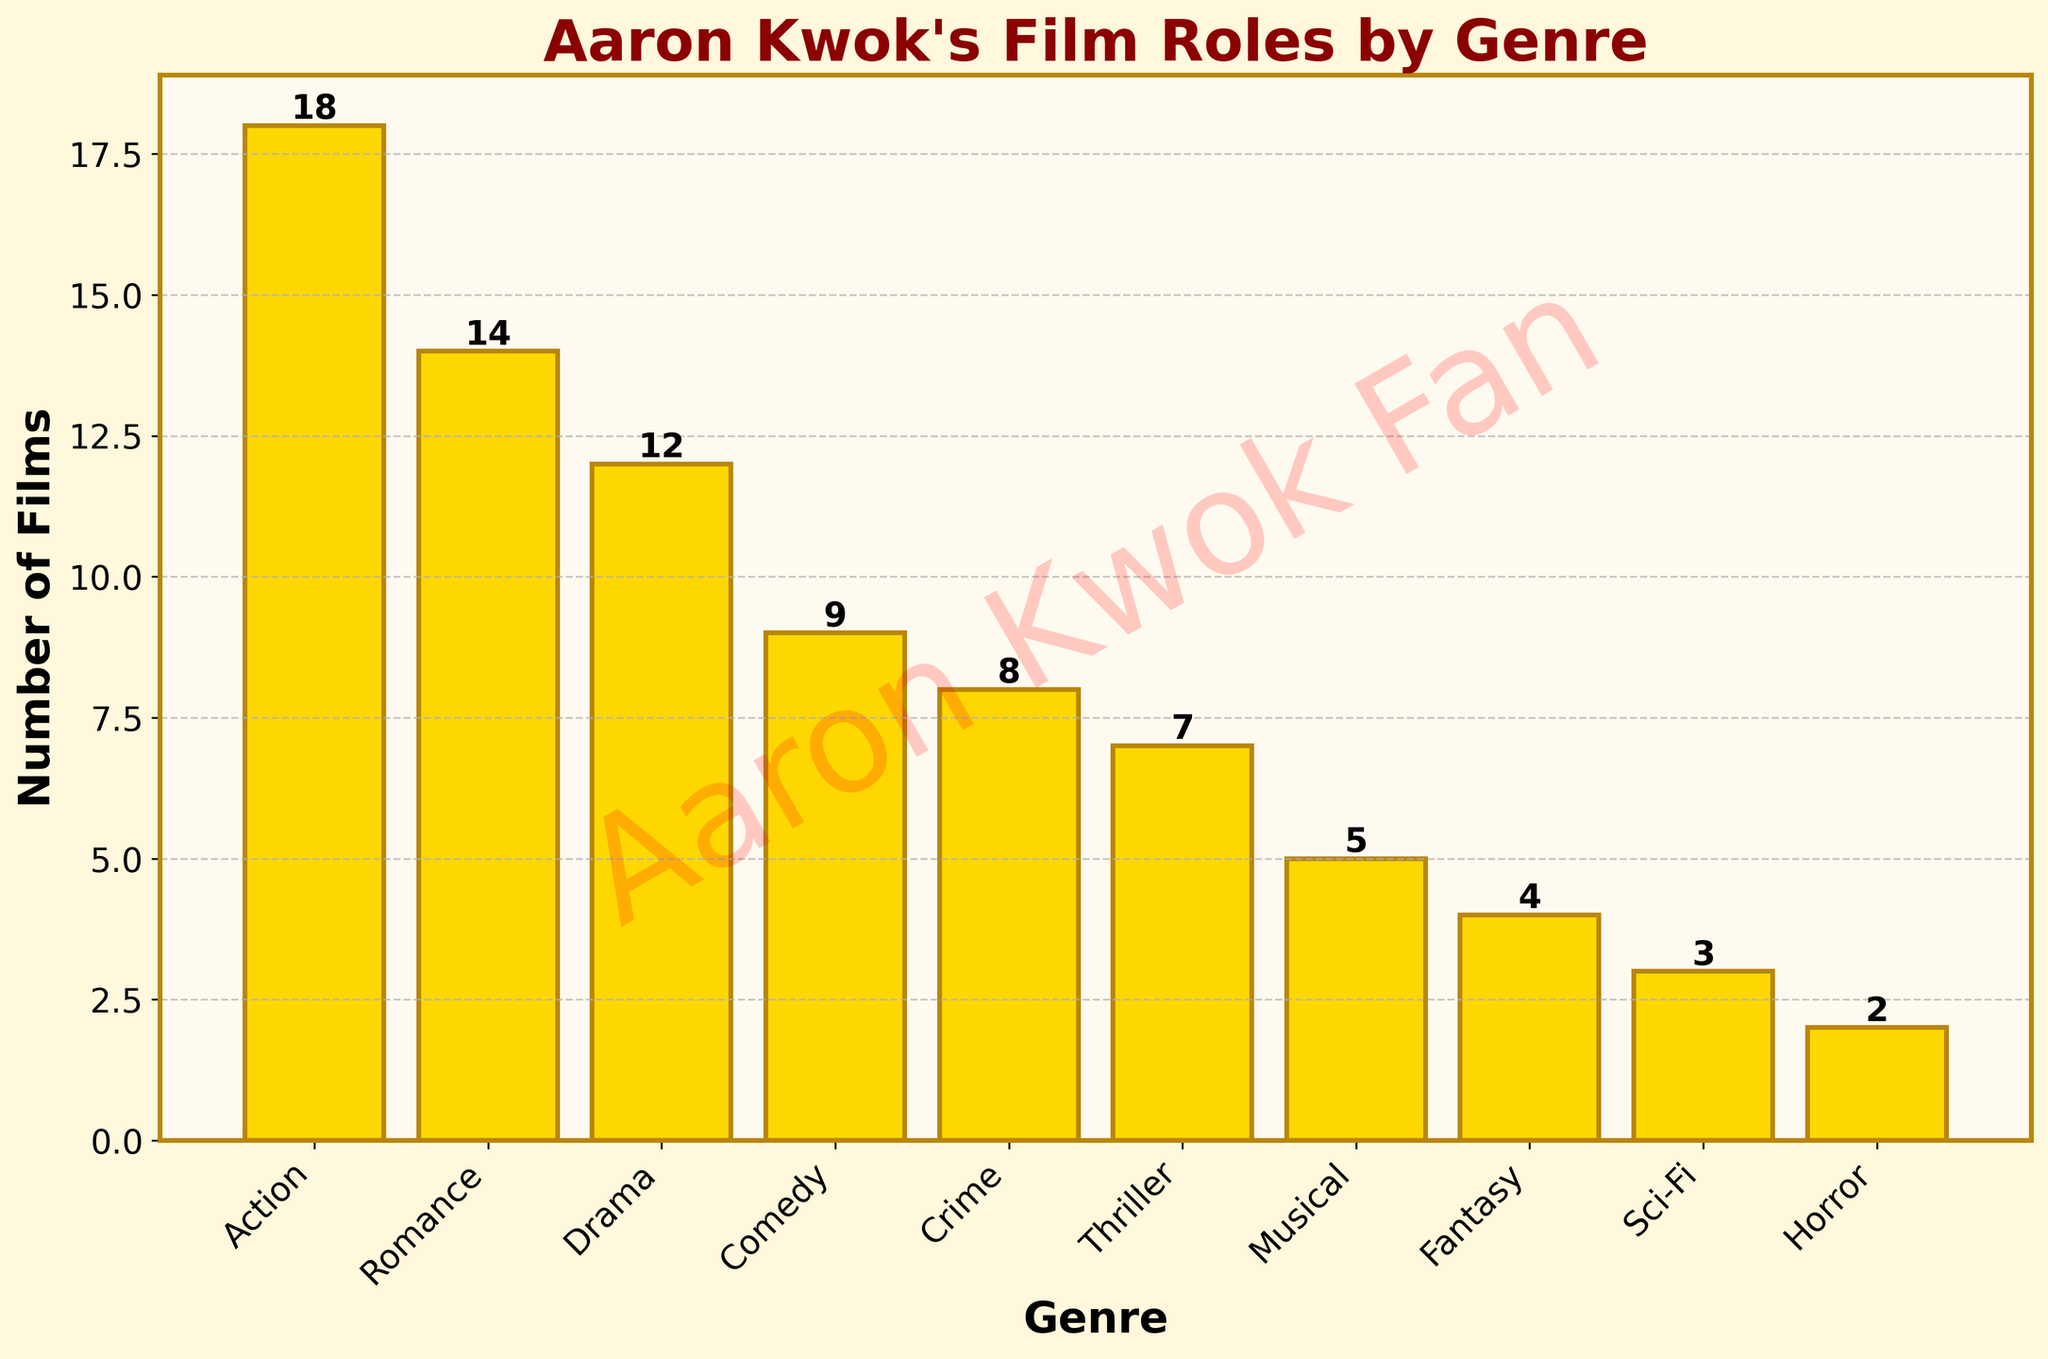Which genre has the highest number of films? By looking at the heights of the bars, we can see that "Action" has the tallest bar, indicating it has the highest number of films.
Answer: Action Which genre has the fewest number of films? The shortest bar represents the genre with the fewest films, which is "Horror".
Answer: Horror How many more Action films are there than Comedy films? The number of Action films is 18 and the number of Comedy films is 9. The difference is 18 - 9 = 9.
Answer: 9 Is the number of Romance films greater than the number of Thriller films? Comparing the heights of the bars, Romance films are 14 and Thriller films are 7. Since 14 is greater than 7, the answer is yes.
Answer: Yes What is the total number of films across the genres of Crime, Thriller, and Musical combined? Summing the numbers of Crime (8), Thriller (7), and Musical (5) gives us 8 + 7 + 5 = 20.
Answer: 20 Which genre(s) have more than 10 films? By examining the heights of the bars, we see that the genres with more than 10 films are Action (18), Romance (14), and Drama (12).
Answer: Action, Romance, Drama How many genres have fewer than 5 films? By counting the bars whose heights are less than 5, we find that there are 3 genres: Fantasy (4), Sci-Fi (3), and Horror (2).
Answer: 3 What's the average number of films in the genres with the top three bar heights? The top three bar heights correspond to Action (18), Romance (14), and Drama (12). These numbers sum up to 18 + 14 + 12 = 44. The average is 44 / 3 = 14.67.
Answer: 14.67 How many more Action films are there than the total of Sci-Fi and Horror films combined? Sci-Fi has 3 films and Horror has 2 films. Their total is 3 + 2 = 5. The number of Action films is 18. The difference is 18 - 5 = 13.
Answer: 13 What visual feature can you see in the background of the chart? The background of the chart contains a watermark that reads 'Aaron Kwok Fan' in a red, semi-transparent font, rotated at an angle.
Answer: 'Aaron Kwok Fan' watermark 